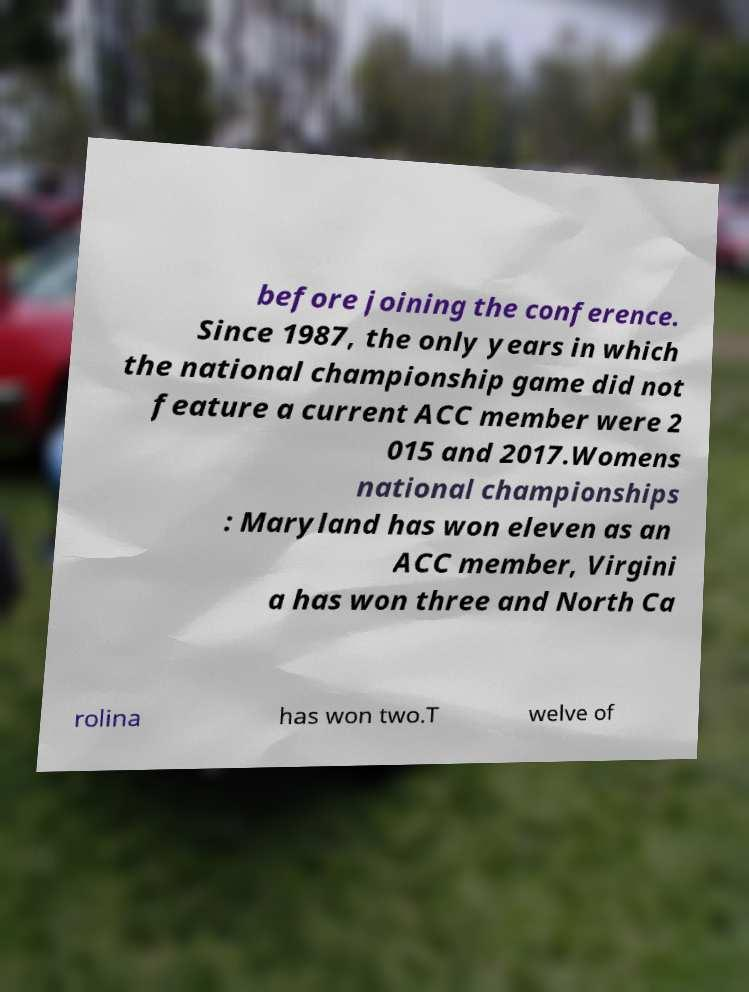There's text embedded in this image that I need extracted. Can you transcribe it verbatim? before joining the conference. Since 1987, the only years in which the national championship game did not feature a current ACC member were 2 015 and 2017.Womens national championships : Maryland has won eleven as an ACC member, Virgini a has won three and North Ca rolina has won two.T welve of 